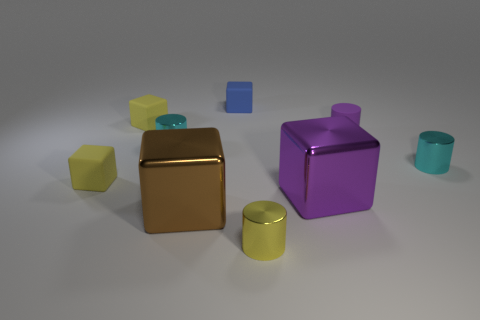There is a purple object that is the same size as the yellow cylinder; what is its shape? The purple object in question is indeed a cylinder, identical in shape to the yellow one but with a different hue, indicating variety in colors within the group of objects presented. 